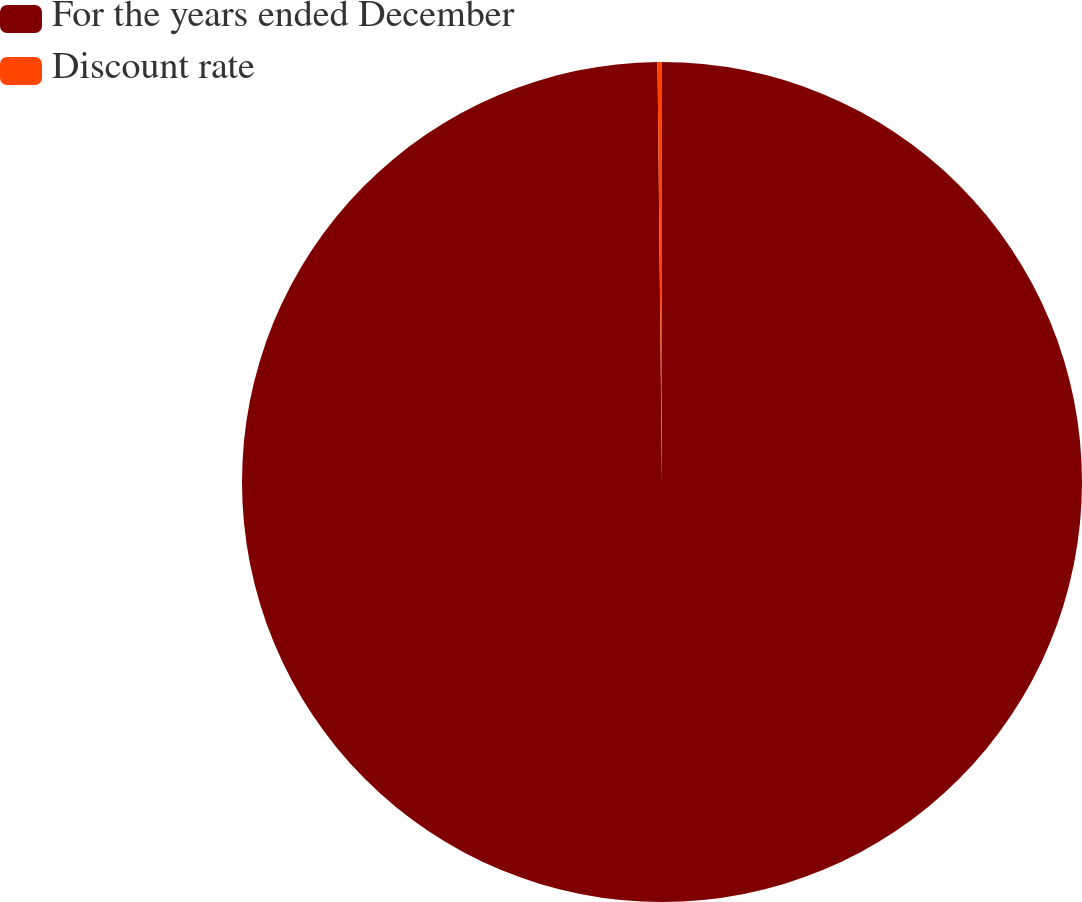Convert chart. <chart><loc_0><loc_0><loc_500><loc_500><pie_chart><fcel>For the years ended December<fcel>Discount rate<nl><fcel>99.83%<fcel>0.17%<nl></chart> 